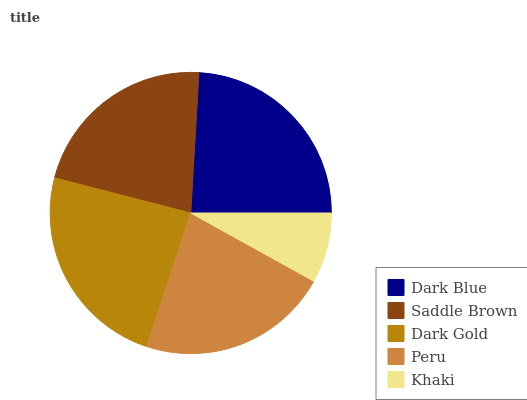Is Khaki the minimum?
Answer yes or no. Yes. Is Dark Blue the maximum?
Answer yes or no. Yes. Is Saddle Brown the minimum?
Answer yes or no. No. Is Saddle Brown the maximum?
Answer yes or no. No. Is Dark Blue greater than Saddle Brown?
Answer yes or no. Yes. Is Saddle Brown less than Dark Blue?
Answer yes or no. Yes. Is Saddle Brown greater than Dark Blue?
Answer yes or no. No. Is Dark Blue less than Saddle Brown?
Answer yes or no. No. Is Peru the high median?
Answer yes or no. Yes. Is Peru the low median?
Answer yes or no. Yes. Is Saddle Brown the high median?
Answer yes or no. No. Is Saddle Brown the low median?
Answer yes or no. No. 